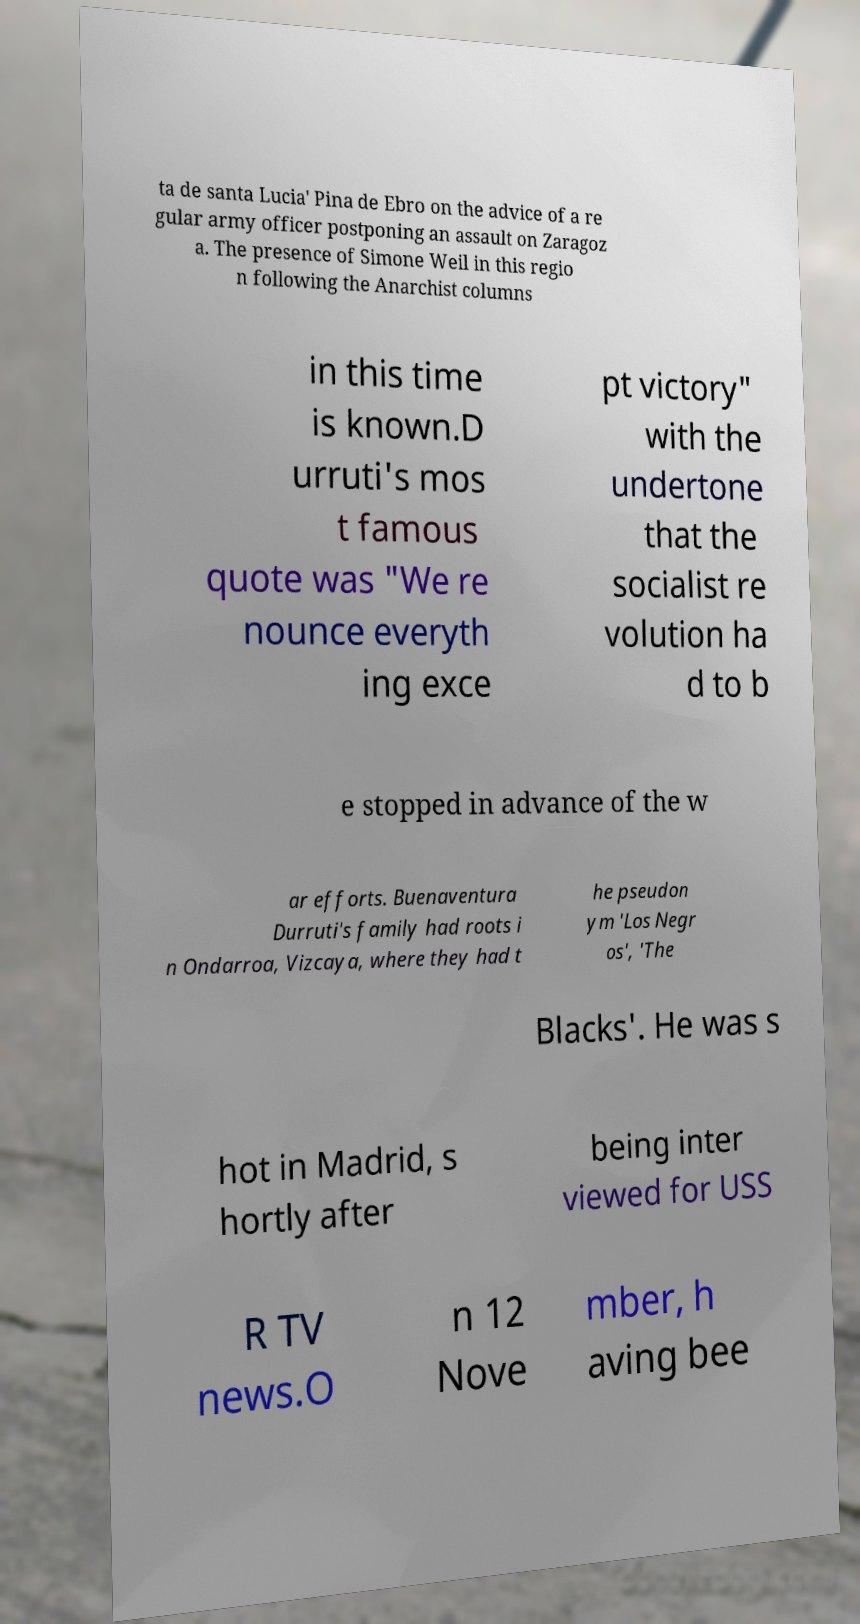For documentation purposes, I need the text within this image transcribed. Could you provide that? ta de santa Lucia' Pina de Ebro on the advice of a re gular army officer postponing an assault on Zaragoz a. The presence of Simone Weil in this regio n following the Anarchist columns in this time is known.D urruti's mos t famous quote was "We re nounce everyth ing exce pt victory" with the undertone that the socialist re volution ha d to b e stopped in advance of the w ar efforts. Buenaventura Durruti's family had roots i n Ondarroa, Vizcaya, where they had t he pseudon ym 'Los Negr os', 'The Blacks'. He was s hot in Madrid, s hortly after being inter viewed for USS R TV news.O n 12 Nove mber, h aving bee 